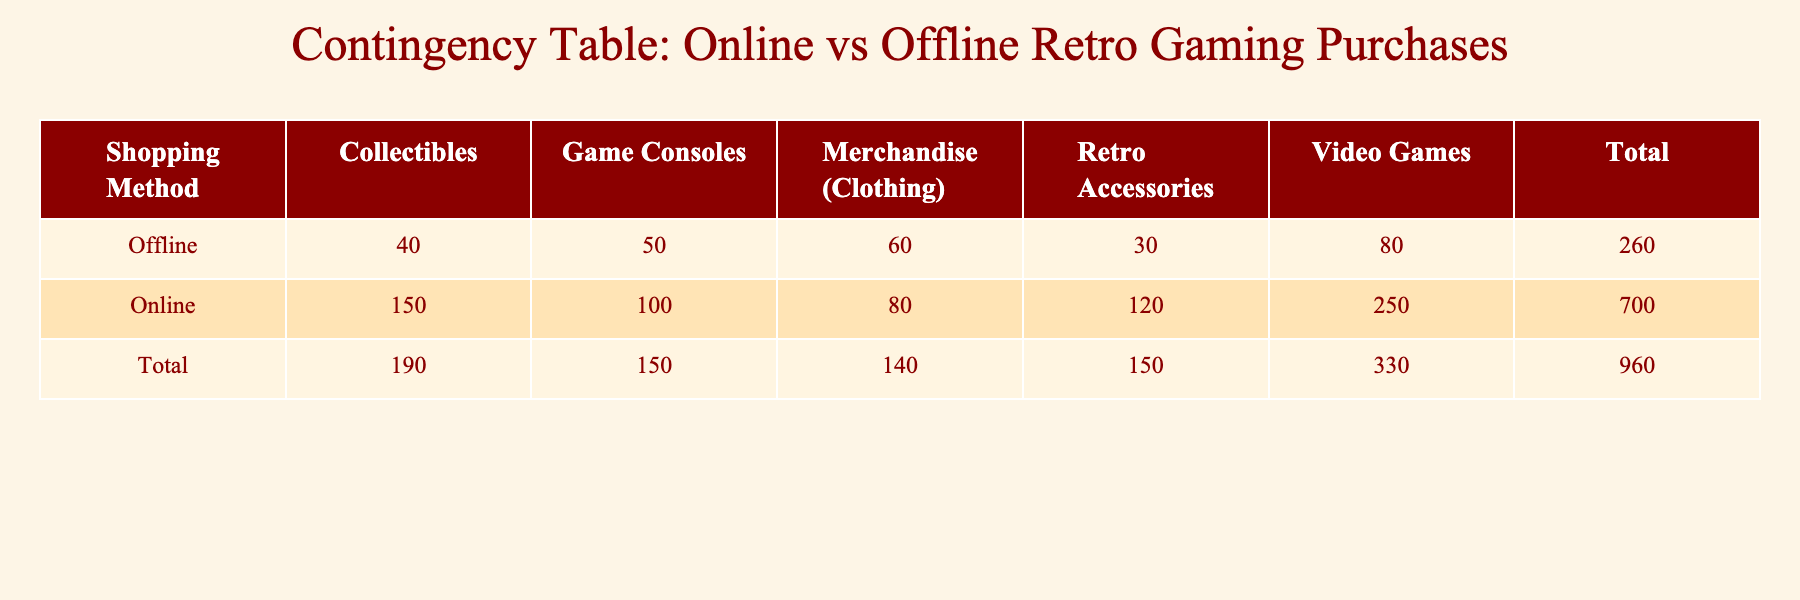What is the total frequency of video games purchased online? The total frequency for video games purchased online is directly listed in the table under the "Online" row and "Video Games" column. This value is 250.
Answer: 250 What is the total frequency of retro accessories purchased offline? The total frequency for retro accessories purchased offline can be found in the table under the "Offline" row and "Retro Accessories" column. This value is 30.
Answer: 30 How many more collectibles were purchased online compared to offline? To find the difference, we first note the online collectibles frequency of 150 and the offline collectibles frequency of 40. The difference is 150 - 40 = 110.
Answer: 110 What is the total frequency of purchases made online? To find the total frequency for purchases made online, we add the frequencies for each purchase type under the "Online" row: 250 (Video Games) + 100 (Game Consoles) + 150 (Collectibles) + 80 (Merchandise) + 120 (Retro Accessories) = 700.
Answer: 700 Is the total frequency of merchandise (clothing) purchased offline greater than those purchased online? The total frequency for merchandise (clothing) purchased offline is 60, while the total for purchases online is 80. Since 60 is not greater than 80, the answer is no.
Answer: No What percentage of total purchases was made online? First, we calculate the total purchases, which is the sum of all frequencies: 250 + 100 + 150 + 80 + 120 + 80 + 50 + 40 + 60 + 30 = 960. The online purchases total 700, so the percentage is (700 / 960) * 100 = 72.92%.
Answer: 72.92% Which type of purchase has the highest frequency of offline purchases? Looking through the table, we identify the frequencies for offline purchases: 80 (Video Games), 50 (Game Consoles), 40 (Collectibles), 60 (Merchandise), and 30 (Retro Accessories). The highest frequency is 80 for Video Games.
Answer: Video Games How many total retro accessories were purchased, both online and offline? To find the total retro accessories purchased, we add the frequencies for both online (120) and offline (30): 120 + 30 = 150.
Answer: 150 What is the combined total frequency for game consoles purchased online and offline? We locate the frequency for game consoles purchased online (100) and offline (50). Adding both gives us a combined total of 100 + 50 = 150.
Answer: 150 